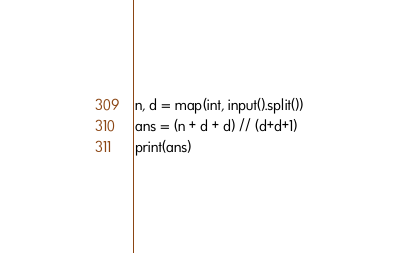<code> <loc_0><loc_0><loc_500><loc_500><_Python_>n, d = map(int, input().split())
ans = (n + d + d) // (d+d+1)
print(ans)</code> 